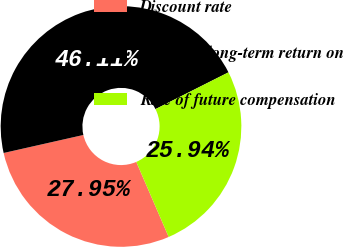Convert chart. <chart><loc_0><loc_0><loc_500><loc_500><pie_chart><fcel>Discount rate<fcel>Expected long-term return on<fcel>Rate of future compensation<nl><fcel>27.95%<fcel>46.11%<fcel>25.94%<nl></chart> 